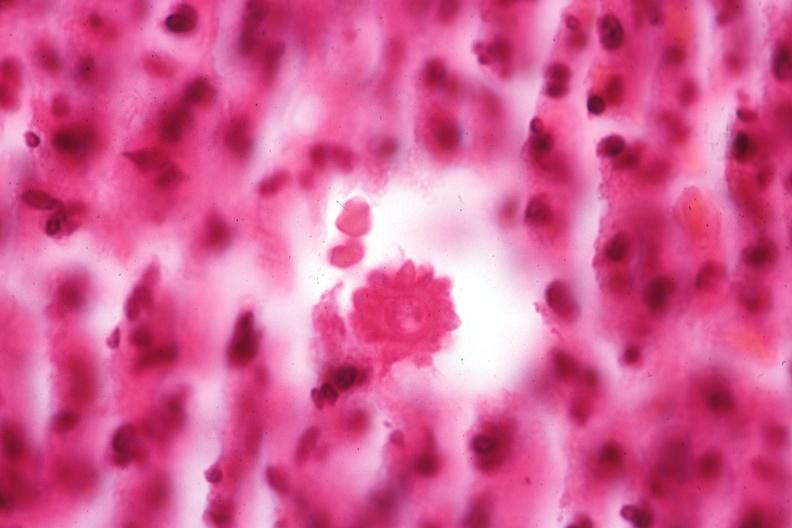where is this?
Answer the question using a single word or phrase. Skin 